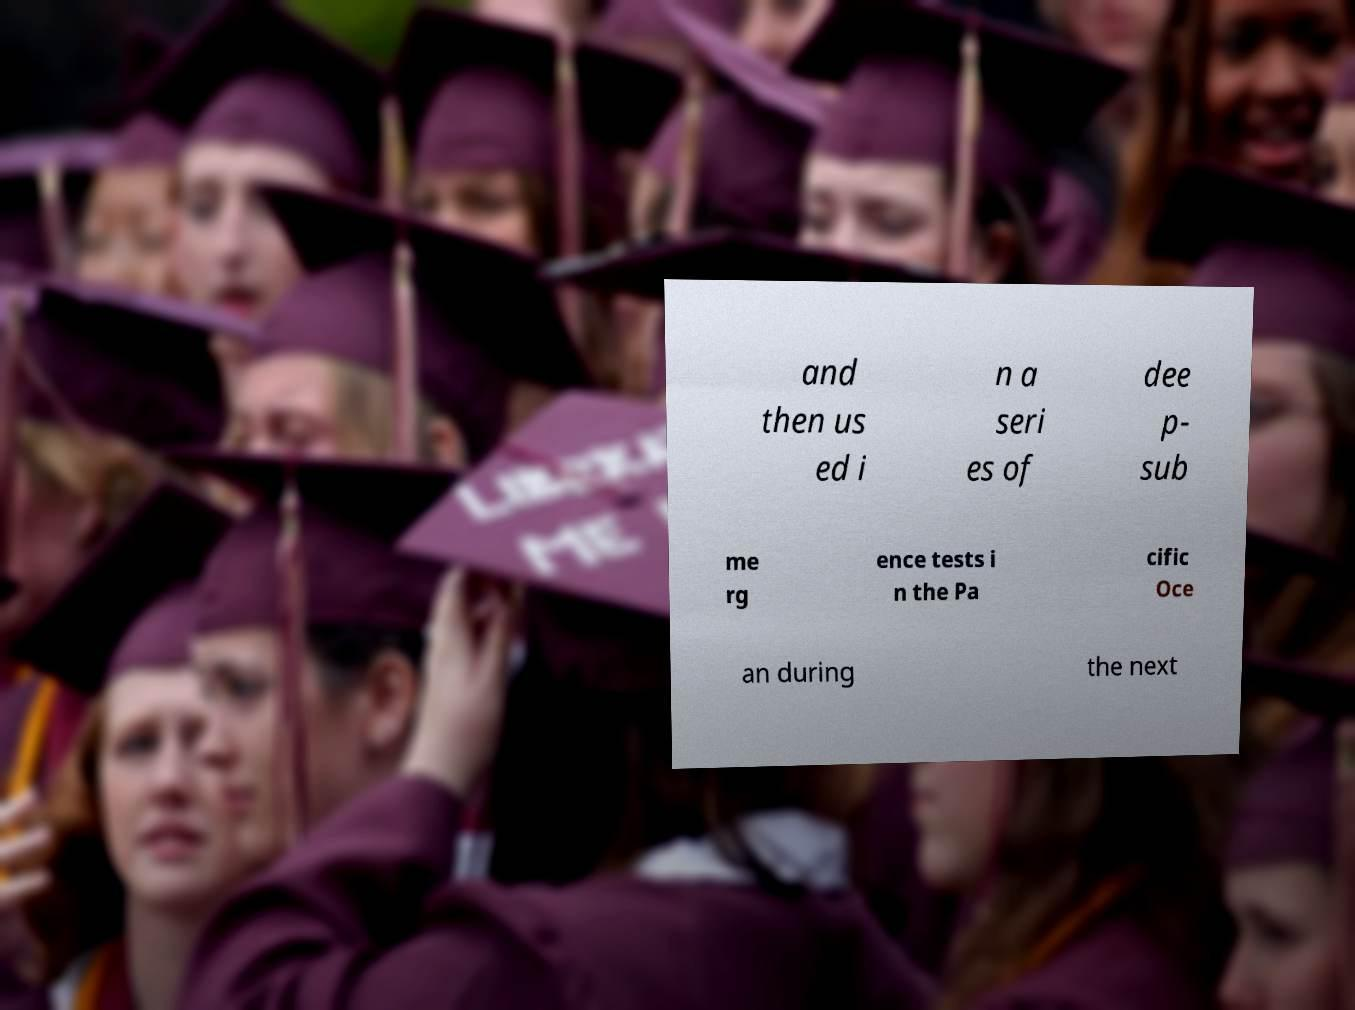Please read and relay the text visible in this image. What does it say? and then us ed i n a seri es of dee p- sub me rg ence tests i n the Pa cific Oce an during the next 